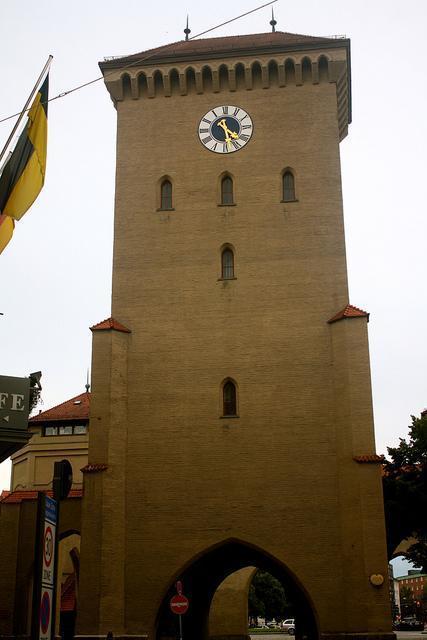How many people are wearing sunglasses?
Give a very brief answer. 0. 